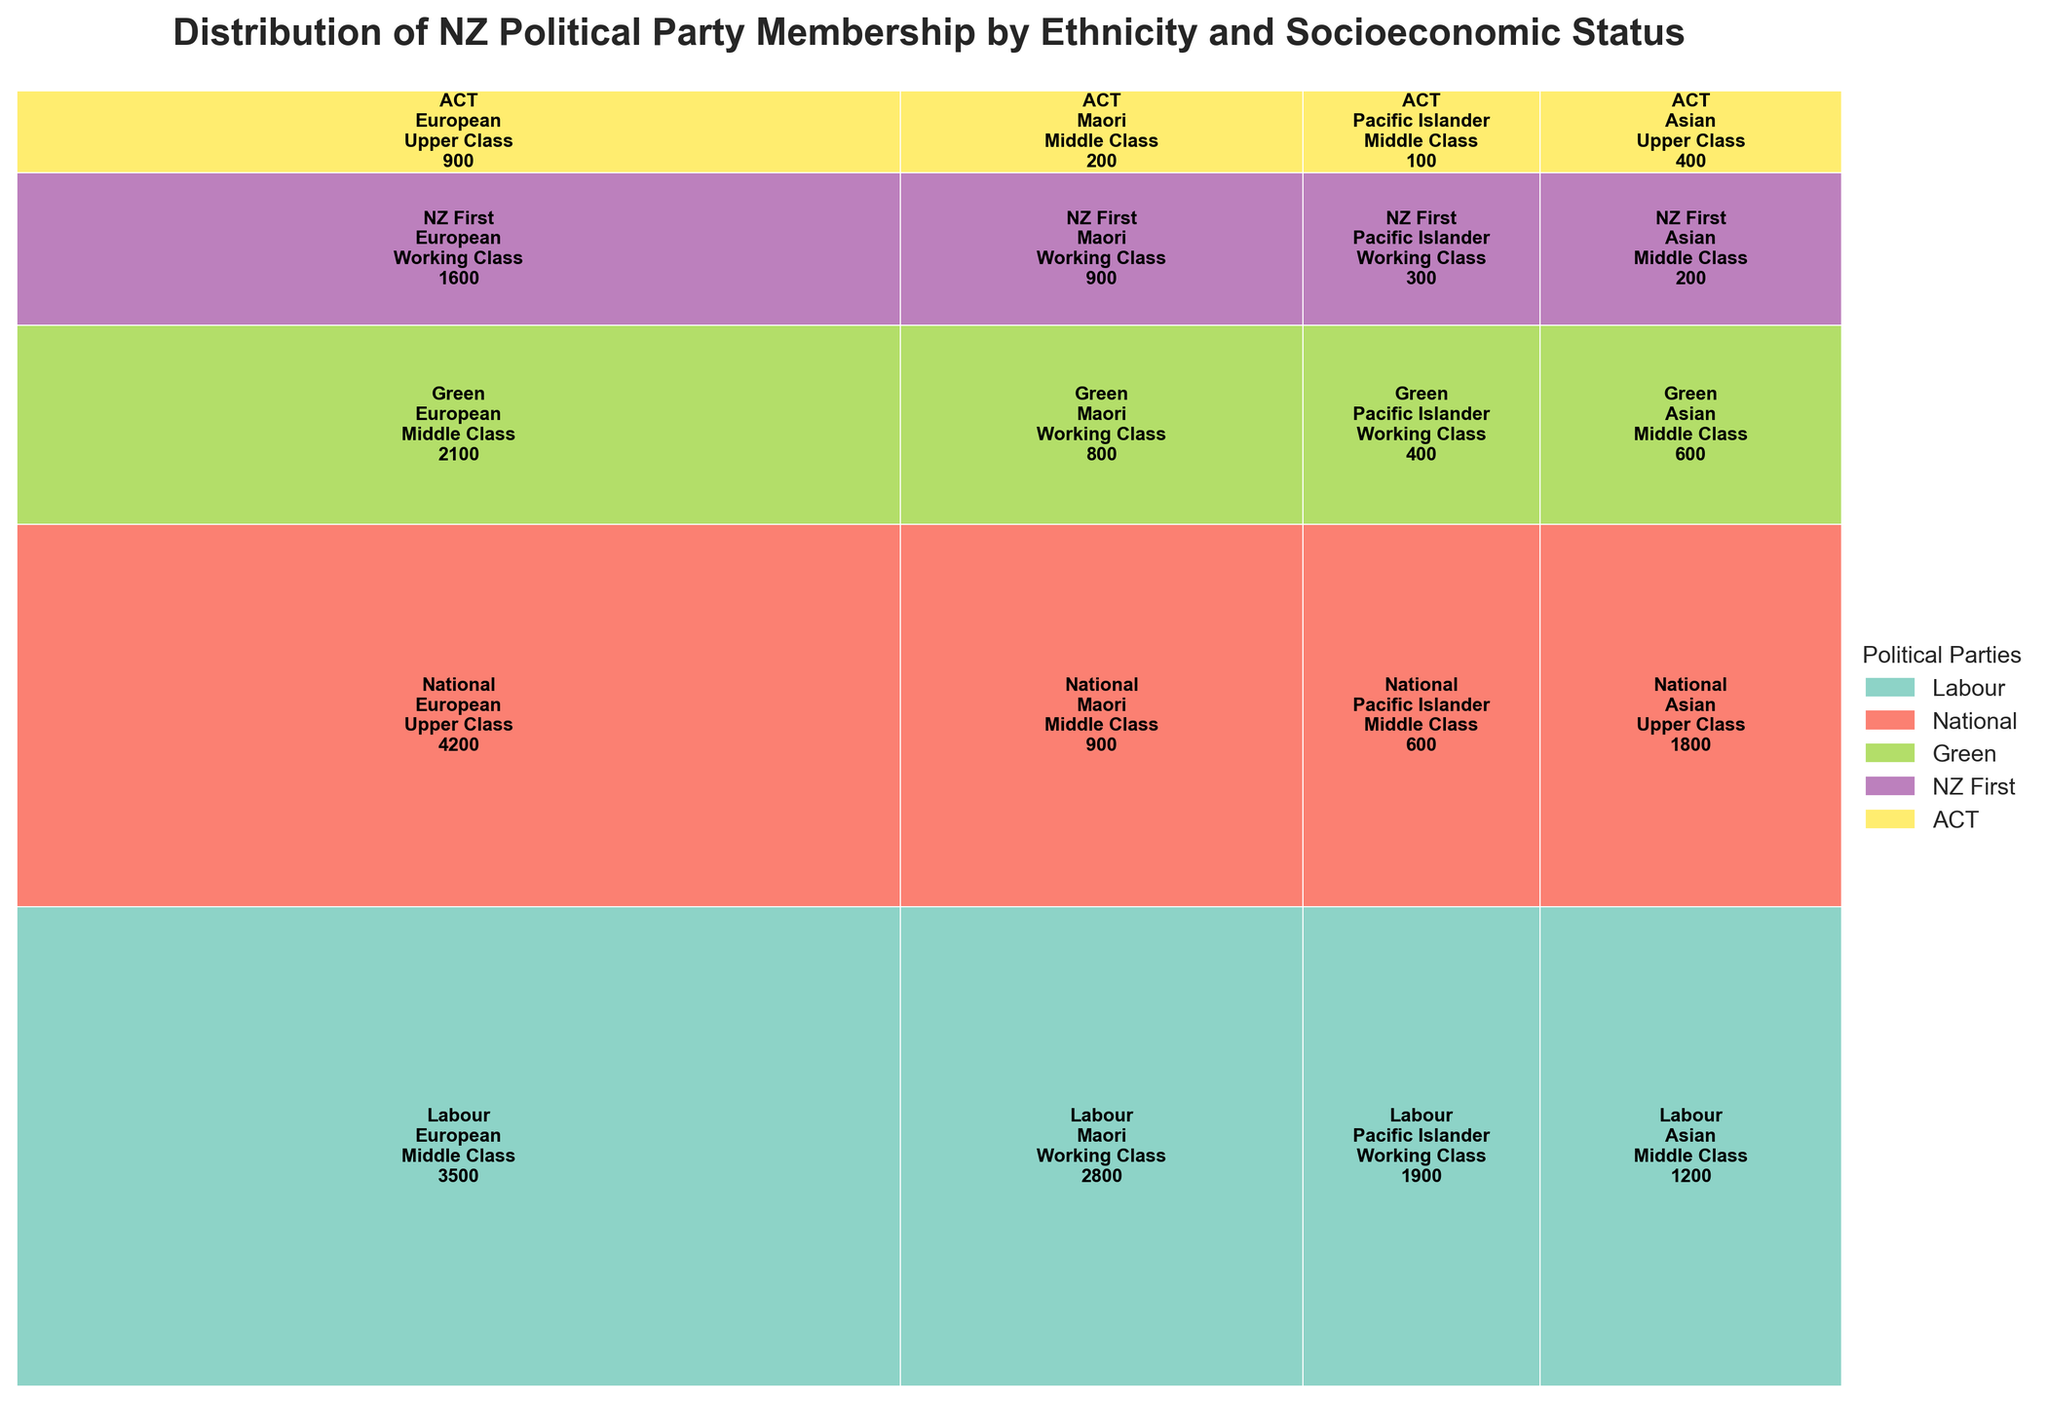What is the title of the mosaic plot? The title of the mosaic plot is usually found at the top of the figure. It summarizes the content of the plot.
Answer: Distribution of NZ Political Party Membership by Ethnicity and Socioeconomic Status Which political party has the highest membership among European upper class individuals? Look at the each party's sections labeled for 'European' and 'Upper Class'. Compare the values and identify the highest.
Answer: National How many total memberships does the Labour party have across all ethnicities and socioeconomic statuses? Sum up all the membership values for the Labour party across different ethnicities and socioeconomic statuses. The values to sum are 3500, 2800, 1900, and 1200.
Answer: 9400 Which ethnicity has the highest number of middle class memberships overall? Look at the different ethnic groups and add up the memberships for 'Middle Class' from all parties for each ethnicity. Compare the sums to find the highest.
Answer: European Between Maori and Pacific Islander working class, which has higher membership in the Green party? Check the membership values for 'Maori' and 'Pacific Islander' under 'Working Class' within the Green party, then compare the two values (800 for Maori and 400 for Pacific Islander).
Answer: Maori What is the combined membership of the Asian middle class in the Labour and Green parties? Add the membership values for 'Asian Middle Class' under the Labour party and the Green party. These values are 1200 and 600.
Answer: 1800 Which party has the lowest representation among Pacific Islander middle class individuals? Check and compare the membership values for 'Pacific Islander' under 'Middle Class' across all parties. Identify the party with the lowest value.
Answer: ACT How does the membership of European middle class in the Green party compare to Pacific Islander working class in NZ First? Compare the membership values of 'European Middle Class' in the Green party (2100) and 'Pacific Islander Working Class' in NZ First (300).
Answer: Larger What is the total membership for NZ First among all socioeconomic statuses and ethnicities? Sum up all membership numbers for NZ First across the different categories. The values to sum are 1600 (European, Working Class), 900 (Maori, Working Class), 300 (Pacific Islander, Working Class), and 200 (Asian, Middle Class).
Answer: 3000 Which party has the widest ethnic representation (i.e., has members from all four ethnic groups)? Look at the membership records for each party and check which parties have membership from all four ethnicities: European, Maori, Pacific Islander, and Asian.
Answer: Labour 